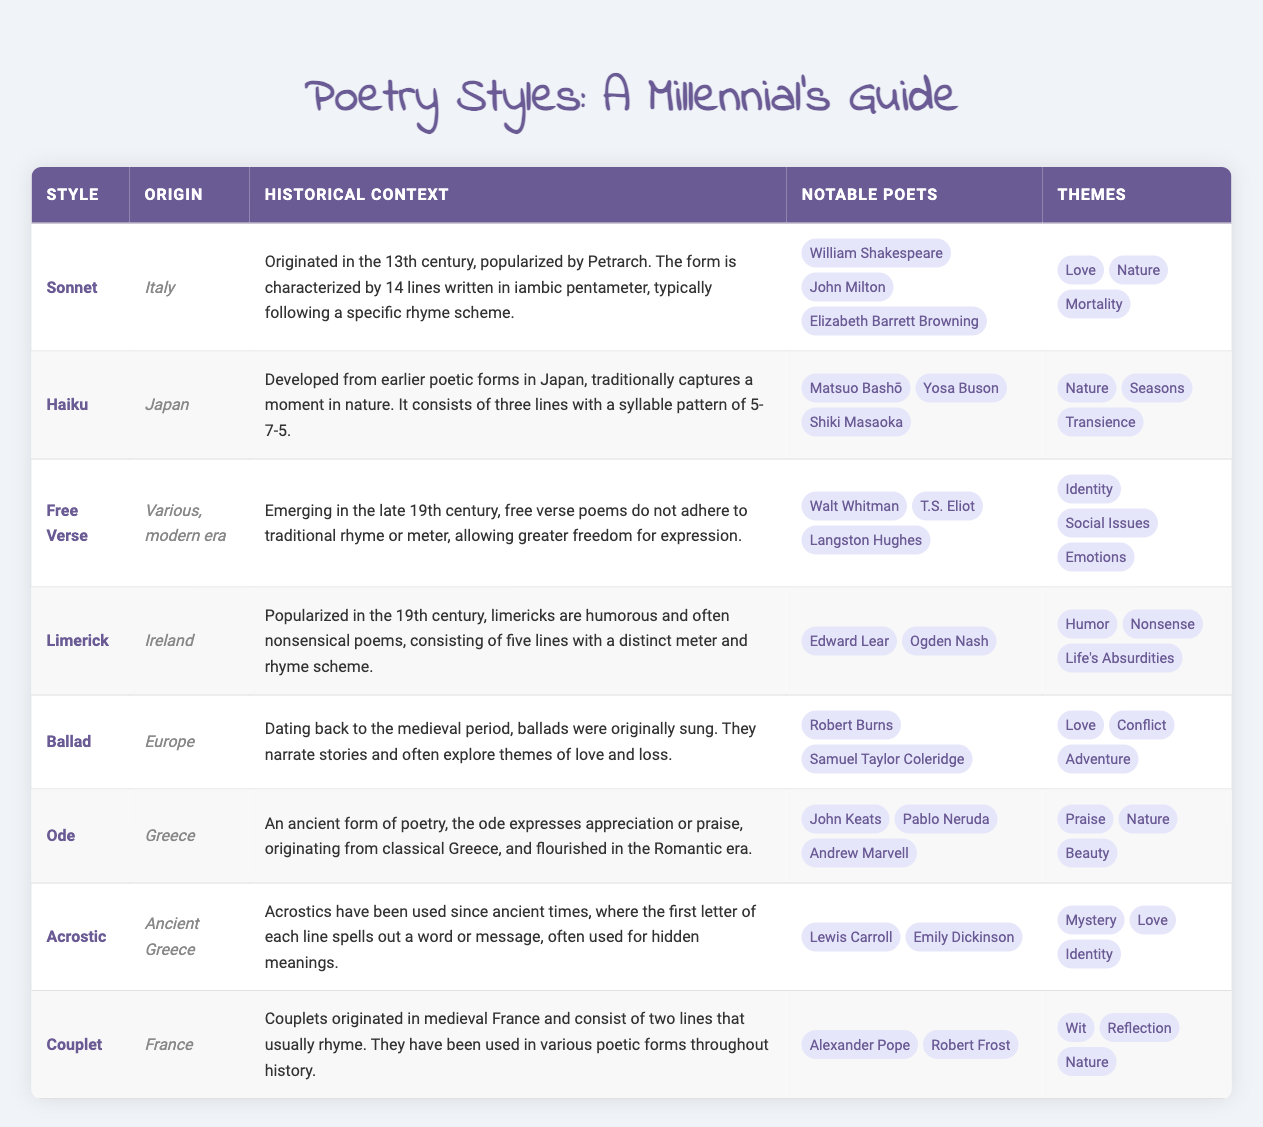What is the origin of the Sonnet? The table explicitly states that the origin of the Sonnet is Italy.
Answer: Italy Which style has themes related to transience? From the table, the themes for Haiku include transience.
Answer: Haiku How many notable poets are listed for the Limerick? The table displays two notable poets for the Limerick: Edward Lear and Ogden Nash. Thus, there are 2 notable poets.
Answer: 2 What are the themes of the Ode? The table lists the themes of the Ode as praise, nature, and beauty.
Answer: Praise, nature, beauty Which poetry style originated the earliest? By reviewing the historical contexts, the Ballad is noted as dating back to the medieval period, making it one of the earliest styles listed.
Answer: Ballad Are there more notable poets for the Acrostic than for the Couplet? The Acrostic has two notable poets (Lewis Carroll and Emily Dickinson), while the Couplet has two notable poets (Alexander Pope and Robert Frost). Since both have the same number, the response is no.
Answer: No Which style's themes include both love and conflict? Upon examining the table, the Ballad includes both love and conflict among its themes.
Answer: Ballad How many different origins are represented in the table? The origins listed are Italy, Japan, various (modern), Ireland, Europe, Greece, and ancient Greece, accounting for 7 different origins.
Answer: 7 Is it true that all poetry styles listed have themes related to nature? Examining the themes, it's evident that not all styles include nature; for instance, Limericks are focused more on humor and nonsense. Therefore, the answer is no.
Answer: No 